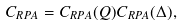Convert formula to latex. <formula><loc_0><loc_0><loc_500><loc_500>C _ { R P A } = C _ { R P A } ( Q ) C _ { R P A } ( \Delta ) ,</formula> 